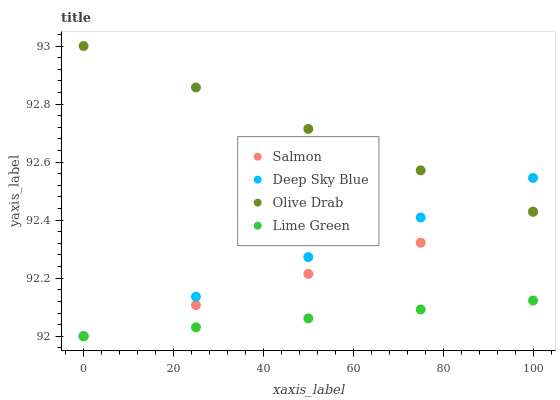Does Lime Green have the minimum area under the curve?
Answer yes or no. Yes. Does Olive Drab have the maximum area under the curve?
Answer yes or no. Yes. Does Salmon have the minimum area under the curve?
Answer yes or no. No. Does Salmon have the maximum area under the curve?
Answer yes or no. No. Is Salmon the smoothest?
Answer yes or no. Yes. Is Deep Sky Blue the roughest?
Answer yes or no. Yes. Is Olive Drab the smoothest?
Answer yes or no. No. Is Olive Drab the roughest?
Answer yes or no. No. Does Lime Green have the lowest value?
Answer yes or no. Yes. Does Olive Drab have the lowest value?
Answer yes or no. No. Does Olive Drab have the highest value?
Answer yes or no. Yes. Does Salmon have the highest value?
Answer yes or no. No. Is Lime Green less than Olive Drab?
Answer yes or no. Yes. Is Olive Drab greater than Lime Green?
Answer yes or no. Yes. Does Salmon intersect Lime Green?
Answer yes or no. Yes. Is Salmon less than Lime Green?
Answer yes or no. No. Is Salmon greater than Lime Green?
Answer yes or no. No. Does Lime Green intersect Olive Drab?
Answer yes or no. No. 